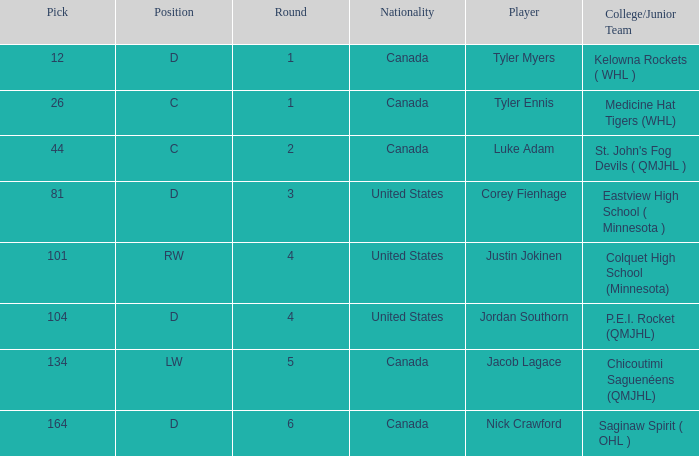What is the nationality of player corey fienhage, who has a pick less than 104? United States. 